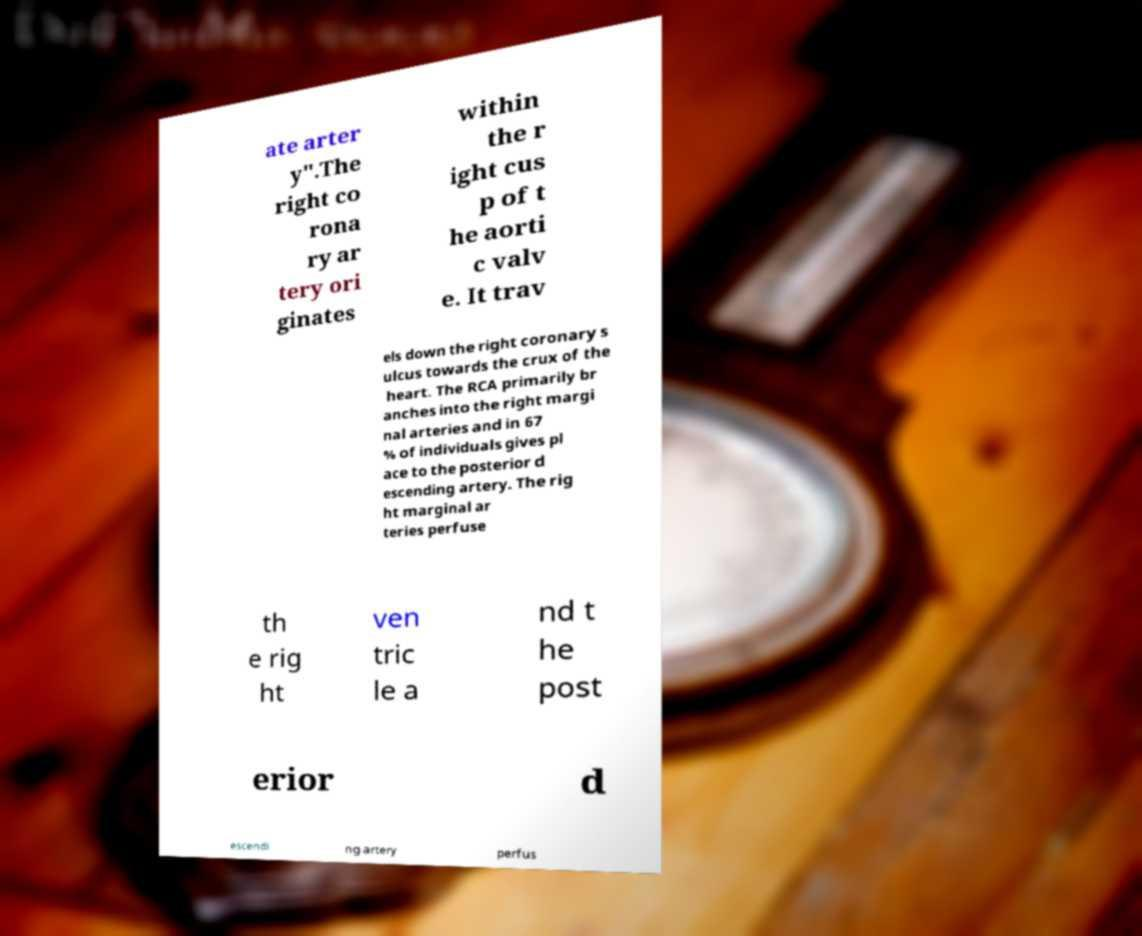Can you read and provide the text displayed in the image?This photo seems to have some interesting text. Can you extract and type it out for me? ate arter y".The right co rona ry ar tery ori ginates within the r ight cus p of t he aorti c valv e. It trav els down the right coronary s ulcus towards the crux of the heart. The RCA primarily br anches into the right margi nal arteries and in 67 % of individuals gives pl ace to the posterior d escending artery. The rig ht marginal ar teries perfuse th e rig ht ven tric le a nd t he post erior d escendi ng artery perfus 